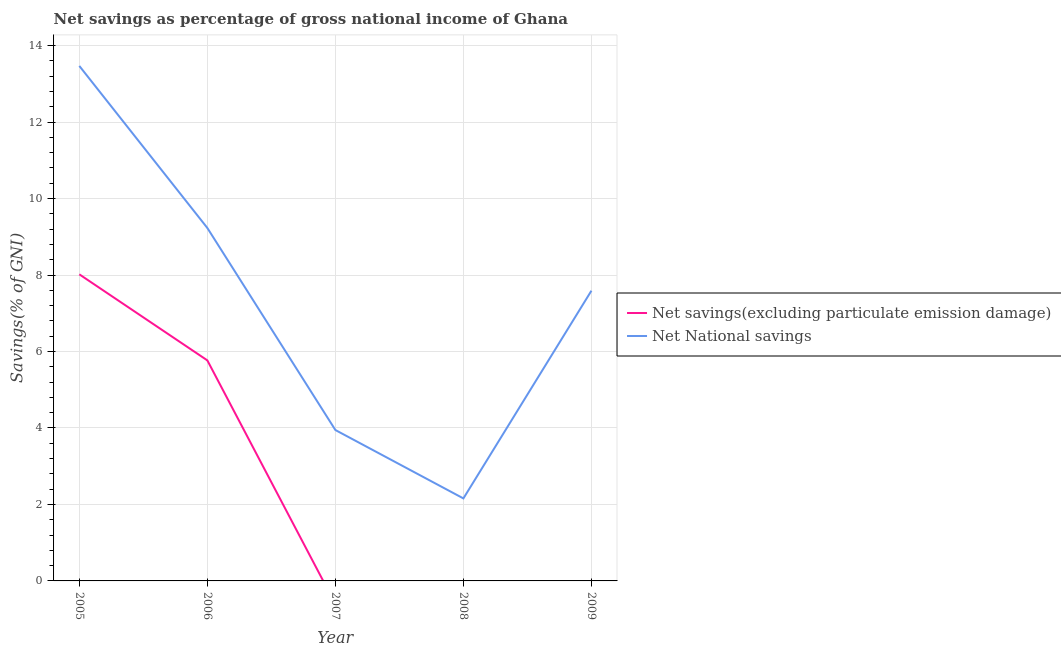Does the line corresponding to net savings(excluding particulate emission damage) intersect with the line corresponding to net national savings?
Provide a short and direct response. No. Across all years, what is the maximum net savings(excluding particulate emission damage)?
Offer a very short reply. 8.02. Across all years, what is the minimum net savings(excluding particulate emission damage)?
Provide a short and direct response. 0. In which year was the net national savings maximum?
Give a very brief answer. 2005. What is the total net national savings in the graph?
Ensure brevity in your answer.  36.39. What is the difference between the net national savings in 2005 and that in 2006?
Offer a very short reply. 4.24. What is the difference between the net national savings in 2006 and the net savings(excluding particulate emission damage) in 2008?
Ensure brevity in your answer.  9.23. What is the average net savings(excluding particulate emission damage) per year?
Give a very brief answer. 2.76. In the year 2005, what is the difference between the net national savings and net savings(excluding particulate emission damage)?
Provide a succinct answer. 5.45. In how many years, is the net savings(excluding particulate emission damage) greater than 7.6 %?
Your response must be concise. 1. What is the ratio of the net national savings in 2007 to that in 2008?
Your answer should be compact. 1.83. Is the net savings(excluding particulate emission damage) in 2005 less than that in 2006?
Offer a very short reply. No. Is the difference between the net savings(excluding particulate emission damage) in 2005 and 2009 greater than the difference between the net national savings in 2005 and 2009?
Ensure brevity in your answer.  Yes. What is the difference between the highest and the second highest net national savings?
Provide a succinct answer. 4.24. What is the difference between the highest and the lowest net savings(excluding particulate emission damage)?
Your answer should be very brief. 8.02. In how many years, is the net savings(excluding particulate emission damage) greater than the average net savings(excluding particulate emission damage) taken over all years?
Your response must be concise. 2. Is the sum of the net national savings in 2006 and 2009 greater than the maximum net savings(excluding particulate emission damage) across all years?
Provide a short and direct response. Yes. Is the net savings(excluding particulate emission damage) strictly greater than the net national savings over the years?
Ensure brevity in your answer.  No. Is the net national savings strictly less than the net savings(excluding particulate emission damage) over the years?
Your answer should be compact. No. How many years are there in the graph?
Offer a very short reply. 5. What is the difference between two consecutive major ticks on the Y-axis?
Provide a succinct answer. 2. Does the graph contain any zero values?
Ensure brevity in your answer.  Yes. Does the graph contain grids?
Keep it short and to the point. Yes. How many legend labels are there?
Provide a short and direct response. 2. How are the legend labels stacked?
Keep it short and to the point. Vertical. What is the title of the graph?
Provide a succinct answer. Net savings as percentage of gross national income of Ghana. Does "Quality of trade" appear as one of the legend labels in the graph?
Your answer should be compact. No. What is the label or title of the X-axis?
Your answer should be very brief. Year. What is the label or title of the Y-axis?
Keep it short and to the point. Savings(% of GNI). What is the Savings(% of GNI) in Net savings(excluding particulate emission damage) in 2005?
Your answer should be compact. 8.02. What is the Savings(% of GNI) of Net National savings in 2005?
Your response must be concise. 13.47. What is the Savings(% of GNI) in Net savings(excluding particulate emission damage) in 2006?
Offer a very short reply. 5.77. What is the Savings(% of GNI) of Net National savings in 2006?
Keep it short and to the point. 9.23. What is the Savings(% of GNI) in Net savings(excluding particulate emission damage) in 2007?
Your answer should be compact. 0. What is the Savings(% of GNI) in Net National savings in 2007?
Keep it short and to the point. 3.95. What is the Savings(% of GNI) of Net National savings in 2008?
Offer a very short reply. 2.16. What is the Savings(% of GNI) of Net savings(excluding particulate emission damage) in 2009?
Offer a very short reply. 0.01. What is the Savings(% of GNI) of Net National savings in 2009?
Ensure brevity in your answer.  7.59. Across all years, what is the maximum Savings(% of GNI) of Net savings(excluding particulate emission damage)?
Make the answer very short. 8.02. Across all years, what is the maximum Savings(% of GNI) of Net National savings?
Offer a very short reply. 13.47. Across all years, what is the minimum Savings(% of GNI) of Net National savings?
Offer a very short reply. 2.16. What is the total Savings(% of GNI) of Net savings(excluding particulate emission damage) in the graph?
Keep it short and to the point. 13.79. What is the total Savings(% of GNI) of Net National savings in the graph?
Keep it short and to the point. 36.39. What is the difference between the Savings(% of GNI) of Net savings(excluding particulate emission damage) in 2005 and that in 2006?
Your answer should be compact. 2.25. What is the difference between the Savings(% of GNI) in Net National savings in 2005 and that in 2006?
Keep it short and to the point. 4.24. What is the difference between the Savings(% of GNI) in Net National savings in 2005 and that in 2007?
Make the answer very short. 9.52. What is the difference between the Savings(% of GNI) of Net National savings in 2005 and that in 2008?
Give a very brief answer. 11.31. What is the difference between the Savings(% of GNI) of Net savings(excluding particulate emission damage) in 2005 and that in 2009?
Make the answer very short. 8.01. What is the difference between the Savings(% of GNI) in Net National savings in 2005 and that in 2009?
Ensure brevity in your answer.  5.88. What is the difference between the Savings(% of GNI) of Net National savings in 2006 and that in 2007?
Keep it short and to the point. 5.28. What is the difference between the Savings(% of GNI) of Net National savings in 2006 and that in 2008?
Your answer should be very brief. 7.07. What is the difference between the Savings(% of GNI) of Net savings(excluding particulate emission damage) in 2006 and that in 2009?
Your answer should be very brief. 5.76. What is the difference between the Savings(% of GNI) of Net National savings in 2006 and that in 2009?
Give a very brief answer. 1.64. What is the difference between the Savings(% of GNI) of Net National savings in 2007 and that in 2008?
Keep it short and to the point. 1.79. What is the difference between the Savings(% of GNI) in Net National savings in 2007 and that in 2009?
Provide a short and direct response. -3.64. What is the difference between the Savings(% of GNI) of Net National savings in 2008 and that in 2009?
Your answer should be very brief. -5.43. What is the difference between the Savings(% of GNI) of Net savings(excluding particulate emission damage) in 2005 and the Savings(% of GNI) of Net National savings in 2006?
Offer a very short reply. -1.21. What is the difference between the Savings(% of GNI) in Net savings(excluding particulate emission damage) in 2005 and the Savings(% of GNI) in Net National savings in 2007?
Your answer should be very brief. 4.07. What is the difference between the Savings(% of GNI) of Net savings(excluding particulate emission damage) in 2005 and the Savings(% of GNI) of Net National savings in 2008?
Ensure brevity in your answer.  5.86. What is the difference between the Savings(% of GNI) of Net savings(excluding particulate emission damage) in 2005 and the Savings(% of GNI) of Net National savings in 2009?
Offer a terse response. 0.43. What is the difference between the Savings(% of GNI) in Net savings(excluding particulate emission damage) in 2006 and the Savings(% of GNI) in Net National savings in 2007?
Your answer should be compact. 1.82. What is the difference between the Savings(% of GNI) of Net savings(excluding particulate emission damage) in 2006 and the Savings(% of GNI) of Net National savings in 2008?
Give a very brief answer. 3.61. What is the difference between the Savings(% of GNI) of Net savings(excluding particulate emission damage) in 2006 and the Savings(% of GNI) of Net National savings in 2009?
Offer a terse response. -1.82. What is the average Savings(% of GNI) in Net savings(excluding particulate emission damage) per year?
Keep it short and to the point. 2.76. What is the average Savings(% of GNI) in Net National savings per year?
Give a very brief answer. 7.28. In the year 2005, what is the difference between the Savings(% of GNI) of Net savings(excluding particulate emission damage) and Savings(% of GNI) of Net National savings?
Offer a terse response. -5.45. In the year 2006, what is the difference between the Savings(% of GNI) of Net savings(excluding particulate emission damage) and Savings(% of GNI) of Net National savings?
Your answer should be compact. -3.46. In the year 2009, what is the difference between the Savings(% of GNI) in Net savings(excluding particulate emission damage) and Savings(% of GNI) in Net National savings?
Provide a short and direct response. -7.58. What is the ratio of the Savings(% of GNI) of Net savings(excluding particulate emission damage) in 2005 to that in 2006?
Provide a short and direct response. 1.39. What is the ratio of the Savings(% of GNI) of Net National savings in 2005 to that in 2006?
Provide a short and direct response. 1.46. What is the ratio of the Savings(% of GNI) in Net National savings in 2005 to that in 2007?
Your answer should be very brief. 3.41. What is the ratio of the Savings(% of GNI) of Net National savings in 2005 to that in 2008?
Ensure brevity in your answer.  6.24. What is the ratio of the Savings(% of GNI) in Net savings(excluding particulate emission damage) in 2005 to that in 2009?
Keep it short and to the point. 884.83. What is the ratio of the Savings(% of GNI) of Net National savings in 2005 to that in 2009?
Keep it short and to the point. 1.77. What is the ratio of the Savings(% of GNI) of Net National savings in 2006 to that in 2007?
Give a very brief answer. 2.34. What is the ratio of the Savings(% of GNI) in Net National savings in 2006 to that in 2008?
Provide a short and direct response. 4.28. What is the ratio of the Savings(% of GNI) in Net savings(excluding particulate emission damage) in 2006 to that in 2009?
Your answer should be compact. 636.49. What is the ratio of the Savings(% of GNI) of Net National savings in 2006 to that in 2009?
Your answer should be compact. 1.22. What is the ratio of the Savings(% of GNI) of Net National savings in 2007 to that in 2008?
Keep it short and to the point. 1.83. What is the ratio of the Savings(% of GNI) in Net National savings in 2007 to that in 2009?
Make the answer very short. 0.52. What is the ratio of the Savings(% of GNI) in Net National savings in 2008 to that in 2009?
Make the answer very short. 0.28. What is the difference between the highest and the second highest Savings(% of GNI) of Net savings(excluding particulate emission damage)?
Offer a very short reply. 2.25. What is the difference between the highest and the second highest Savings(% of GNI) of Net National savings?
Your answer should be compact. 4.24. What is the difference between the highest and the lowest Savings(% of GNI) of Net savings(excluding particulate emission damage)?
Keep it short and to the point. 8.02. What is the difference between the highest and the lowest Savings(% of GNI) in Net National savings?
Provide a short and direct response. 11.31. 